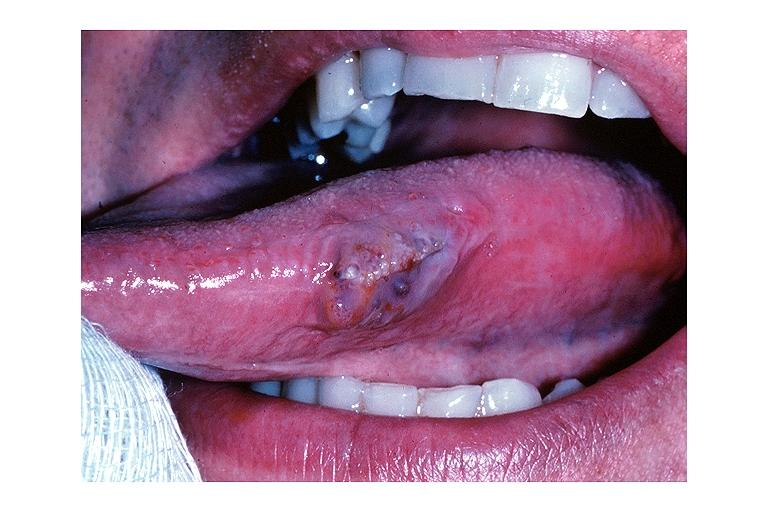what does this image show?
Answer the question using a single word or phrase. Lymphangioma 